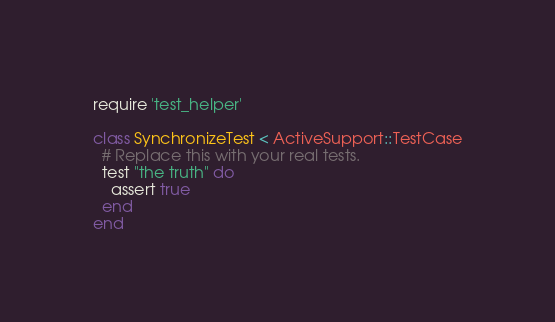<code> <loc_0><loc_0><loc_500><loc_500><_Ruby_>require 'test_helper'

class SynchronizeTest < ActiveSupport::TestCase
  # Replace this with your real tests.
  test "the truth" do
    assert true
  end
end
</code> 